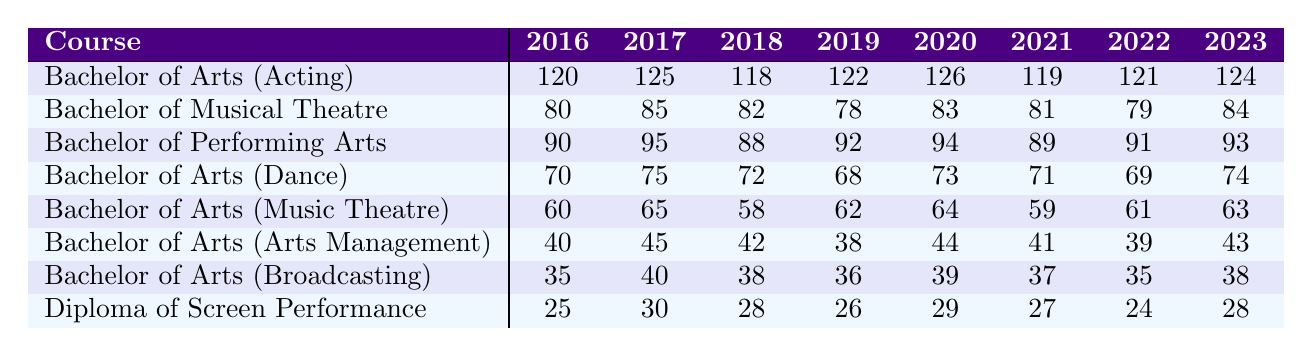What course had the highest enrollment in 2019? Looking at the 2019 column, the highest enrollment is 122 for Bachelor of Arts (Acting), compared to other courses.
Answer: Bachelor of Arts (Acting) What was the enrollment trend for the Bachelor of Musical Theatre from 2016 to 2023? The enrollment increased from 80 in 2016 to 84 in 2023, with minor fluctuations over the years.
Answer: Increased What was the average enrollment for the Bachelor of Arts (Dance) over the years? The enrollments are 70, 75, 72, 68, 73, 71, 69, and 74. Adding these gives 70+75+72+68+73+71+69+74 = 571. There are 8 years, so the average is 571/8 = 71.375, which rounds to 71.
Answer: 71.375 Which course had the lowest enrollment in 2021? In the 2021 column, the lowest value is 24, corresponding to the Diploma of Screen Performance.
Answer: Diploma of Screen Performance What was the increase in enrollment for the Bachelor of Arts (Acting) from 2016 to 2023? The enrollment in 2016 was 120 and in 2023 it was 124. The increase is 124 - 120 = 4.
Answer: 4 Did enrollment for the Bachelor of Arts (Music Theatre) decline at any point between 2016 and 2023? Looking at the enrollments: 60, 65, 58, 62, 64, 59, 61, 63, there was a decline from 65 in 2017 to 58 in 2018.
Answer: Yes What is the total enrollment across all courses in 2020? Adding the values for 2020, we get 126 + 83 + 94 + 73 + 64 + 44 + 39 + 29 = 512. Thus, total enrollment in 2020 is 512.
Answer: 512 Which course showed the most consistent enrollment between 2016 and 2023? By analyzing the data, the Bachelor of Arts (Arts Management) showed fewer fluctuations with values of 40, 45, 42, 38, 44, 41, 39, 43.
Answer: Bachelor of Arts (Arts Management) What was the difference in enrollment between the Bachelor of Performing Arts in 2017 and 2022? The enrollment in 2017 was 95 and in 2022 it was 91. The difference is 95 - 91 = 4.
Answer: 4 What course had a consistent increase each year from 2016 to 2023? The Bachelor of Arts (Acting) had consistent values of 120, 125, 118, 122, 126, 119, 121, and 124, showing fluctuations rather than consistent increase.
Answer: None 